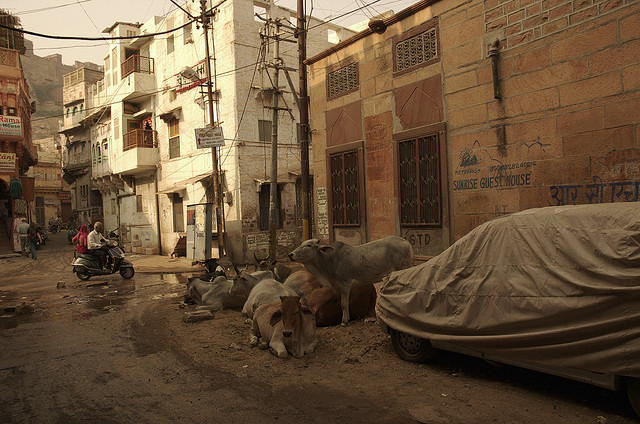Please identify all text content in this image. STD HOUSE GUEST 